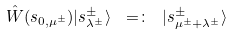Convert formula to latex. <formula><loc_0><loc_0><loc_500><loc_500>\hat { W } ( s _ { 0 , \mu ^ { \pm } } ) | { s } ^ { \pm } _ { \lambda ^ { \pm } } \rangle \ = \colon \ | { s } ^ { \pm } _ { \mu ^ { \pm } + \lambda ^ { \pm } } \rangle</formula> 